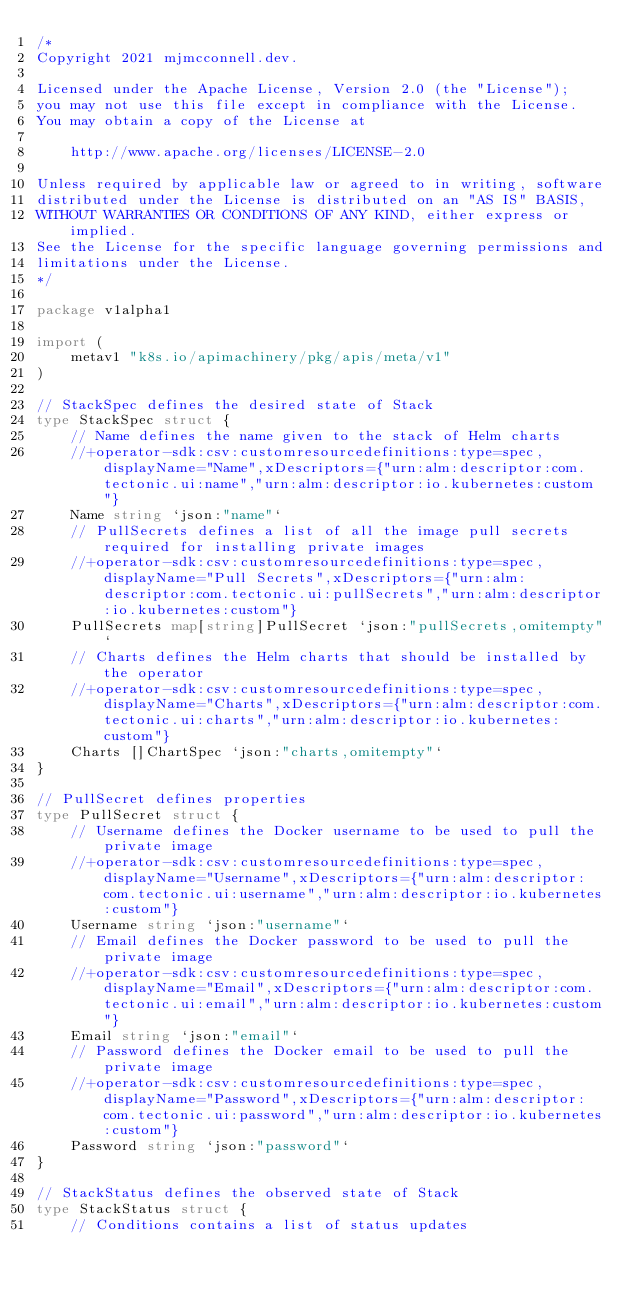Convert code to text. <code><loc_0><loc_0><loc_500><loc_500><_Go_>/*
Copyright 2021 mjmcconnell.dev.

Licensed under the Apache License, Version 2.0 (the "License");
you may not use this file except in compliance with the License.
You may obtain a copy of the License at

    http://www.apache.org/licenses/LICENSE-2.0

Unless required by applicable law or agreed to in writing, software
distributed under the License is distributed on an "AS IS" BASIS,
WITHOUT WARRANTIES OR CONDITIONS OF ANY KIND, either express or implied.
See the License for the specific language governing permissions and
limitations under the License.
*/

package v1alpha1

import (
	metav1 "k8s.io/apimachinery/pkg/apis/meta/v1"
)

// StackSpec defines the desired state of Stack
type StackSpec struct {
	// Name defines the name given to the stack of Helm charts
	//+operator-sdk:csv:customresourcedefinitions:type=spec,displayName="Name",xDescriptors={"urn:alm:descriptor:com.tectonic.ui:name","urn:alm:descriptor:io.kubernetes:custom"}
	Name string `json:"name"`
	// PullSecrets defines a list of all the image pull secrets required for installing private images
	//+operator-sdk:csv:customresourcedefinitions:type=spec,displayName="Pull Secrets",xDescriptors={"urn:alm:descriptor:com.tectonic.ui:pullSecrets","urn:alm:descriptor:io.kubernetes:custom"}
	PullSecrets map[string]PullSecret `json:"pullSecrets,omitempty"`
	// Charts defines the Helm charts that should be installed by the operator
	//+operator-sdk:csv:customresourcedefinitions:type=spec,displayName="Charts",xDescriptors={"urn:alm:descriptor:com.tectonic.ui:charts","urn:alm:descriptor:io.kubernetes:custom"}
	Charts []ChartSpec `json:"charts,omitempty"`
}

// PullSecret defines properties
type PullSecret struct {
	// Username defines the Docker username to be used to pull the private image
	//+operator-sdk:csv:customresourcedefinitions:type=spec,displayName="Username",xDescriptors={"urn:alm:descriptor:com.tectonic.ui:username","urn:alm:descriptor:io.kubernetes:custom"}
	Username string `json:"username"`
	// Email defines the Docker password to be used to pull the private image
	//+operator-sdk:csv:customresourcedefinitions:type=spec,displayName="Email",xDescriptors={"urn:alm:descriptor:com.tectonic.ui:email","urn:alm:descriptor:io.kubernetes:custom"}
	Email string `json:"email"`
	// Password defines the Docker email to be used to pull the private image
	//+operator-sdk:csv:customresourcedefinitions:type=spec,displayName="Password",xDescriptors={"urn:alm:descriptor:com.tectonic.ui:password","urn:alm:descriptor:io.kubernetes:custom"}
	Password string `json:"password"`
}

// StackStatus defines the observed state of Stack
type StackStatus struct {
	// Conditions contains a list of status updates</code> 